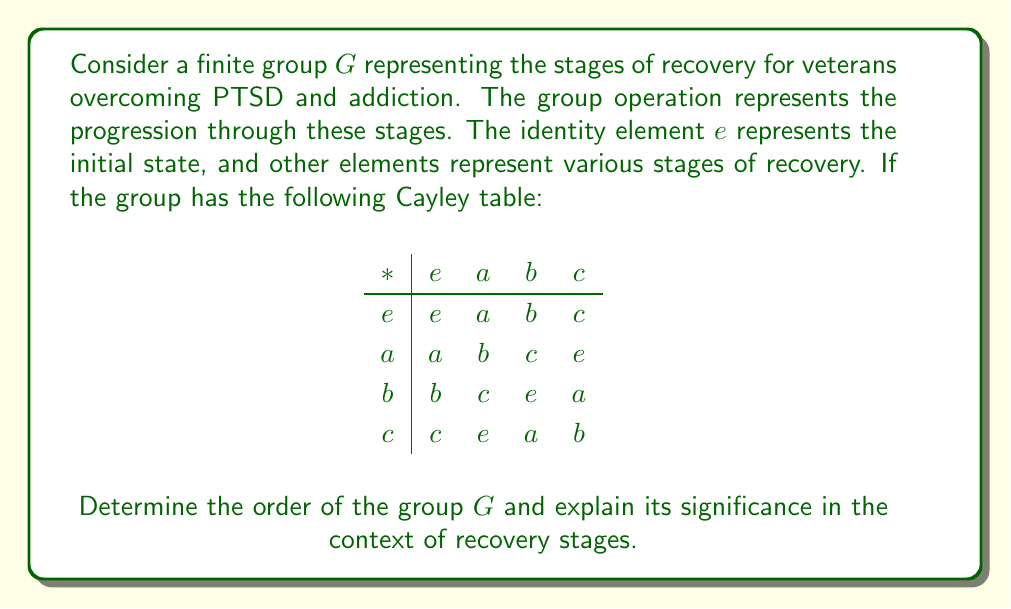Give your solution to this math problem. To determine the order of the finite group $G$, we need to count the number of distinct elements in the group. From the given Cayley table, we can observe:

1. The group has four elements: $e$, $a$, $b$, and $c$.

2. The identity element $e$ represents the initial state of the recovery process.

3. Each element appears exactly once in each row and column, confirming that this is indeed a valid group.

4. The order of an element is the smallest positive integer $n$ such that $a^n = e$. We can see that:
   - $a * a = b$, $a * b = c$, $a * c = e$, so the order of $a$ is 4.
   - Similarly, the orders of $b$ and $c$ are also 4.

5. The order of the group $|G|$ is equal to the number of elements in the group, which is 4.

In the context of recovery stages for veterans:
- $e$ could represent the initial state of seeking help.
- $a$ could represent the stage of acknowledging the problem and committing to recovery.
- $b$ could represent the active treatment and therapy stage.
- $c$ could represent the maintenance and continued support stage.

The cyclic nature of the group (as $a^4 = b^4 = c^4 = e$) could represent the ongoing nature of recovery, where maintaining progress often involves revisiting earlier stages and continuously reinforcing healthy habits and coping mechanisms.

The order of the group being 4 signifies that there are four distinct, crucial stages in this simplified model of the recovery process for veterans overcoming PTSD and addiction.
Answer: $|G| = 4$ 